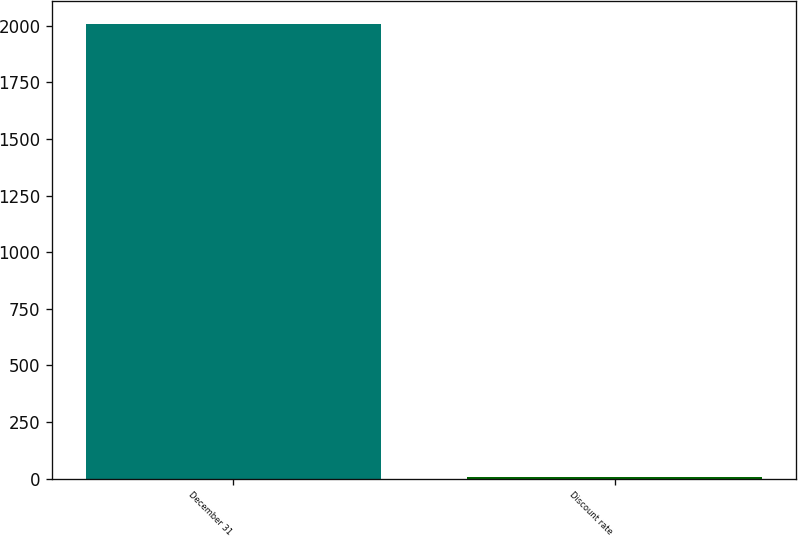<chart> <loc_0><loc_0><loc_500><loc_500><bar_chart><fcel>December 31<fcel>Discount rate<nl><fcel>2007<fcel>6<nl></chart> 